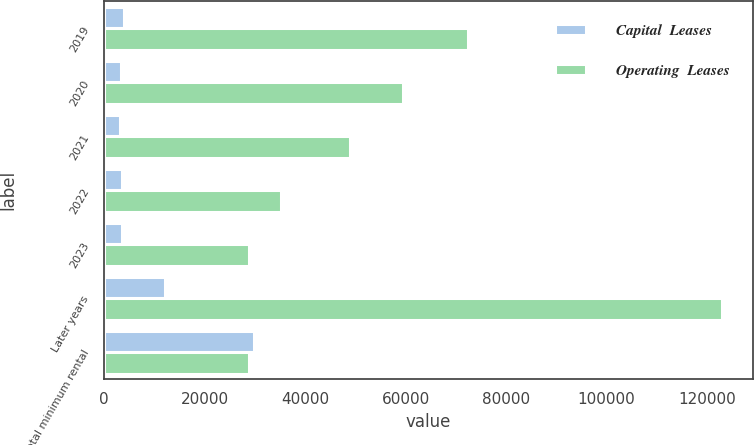Convert chart. <chart><loc_0><loc_0><loc_500><loc_500><stacked_bar_chart><ecel><fcel>2019<fcel>2020<fcel>2021<fcel>2022<fcel>2023<fcel>Later years<fcel>Total minimum rental<nl><fcel>Capital  Leases<fcel>3996<fcel>3345<fcel>3227<fcel>3508<fcel>3624<fcel>12070<fcel>29770<nl><fcel>Operating  Leases<fcel>72353<fcel>59492<fcel>48891<fcel>35233<fcel>28839<fcel>123039<fcel>28839<nl></chart> 